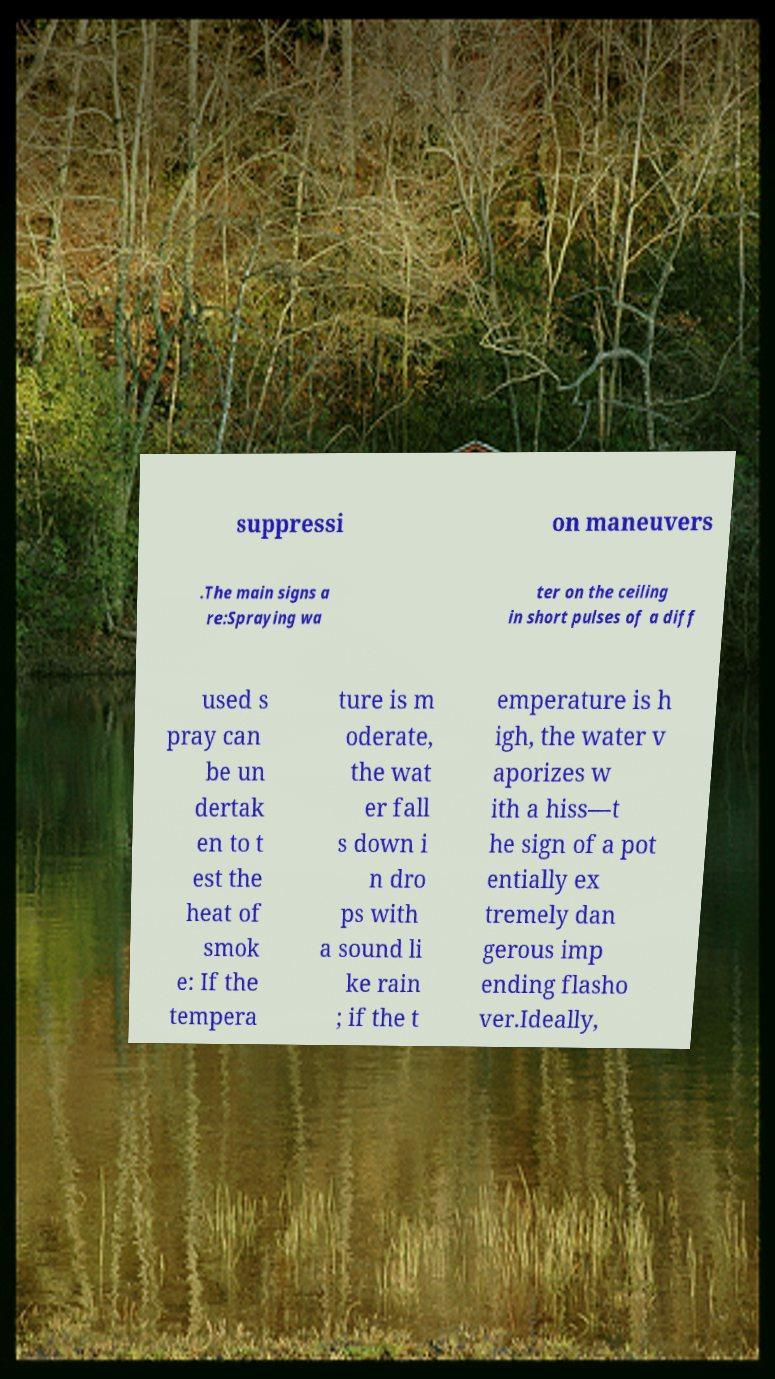Please identify and transcribe the text found in this image. suppressi on maneuvers .The main signs a re:Spraying wa ter on the ceiling in short pulses of a diff used s pray can be un dertak en to t est the heat of smok e: If the tempera ture is m oderate, the wat er fall s down i n dro ps with a sound li ke rain ; if the t emperature is h igh, the water v aporizes w ith a hiss—t he sign of a pot entially ex tremely dan gerous imp ending flasho ver.Ideally, 